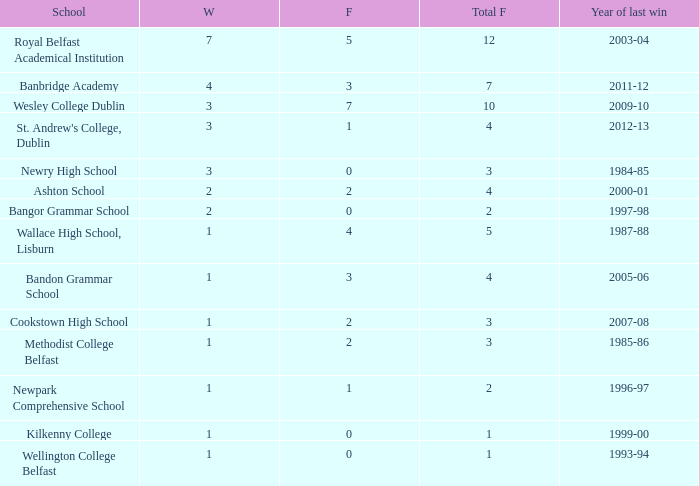What the name of  the school where the last win in 2007-08? Cookstown High School. 